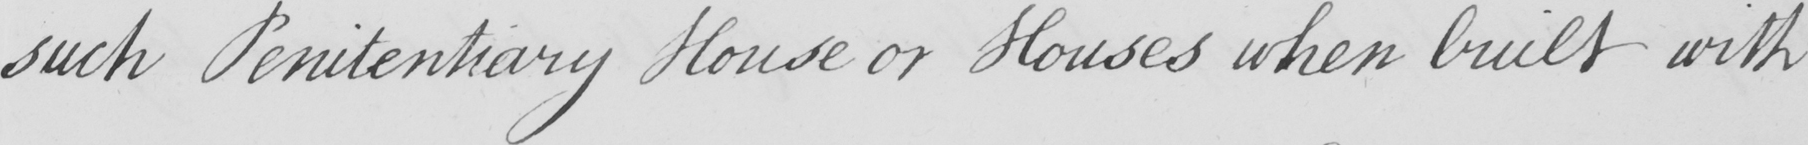Can you read and transcribe this handwriting? such Penitentiary House or Houses when built with 